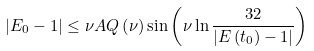<formula> <loc_0><loc_0><loc_500><loc_500>| E _ { 0 } - 1 | \leq \nu A Q \left ( \nu \right ) \sin \left ( \nu \ln \frac { 3 2 } { | E \left ( t _ { 0 } \right ) - 1 | } \right )</formula> 